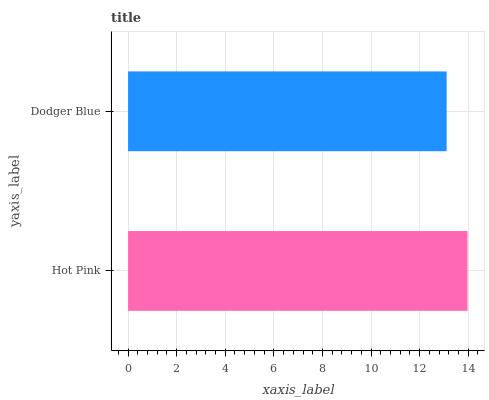Is Dodger Blue the minimum?
Answer yes or no. Yes. Is Hot Pink the maximum?
Answer yes or no. Yes. Is Dodger Blue the maximum?
Answer yes or no. No. Is Hot Pink greater than Dodger Blue?
Answer yes or no. Yes. Is Dodger Blue less than Hot Pink?
Answer yes or no. Yes. Is Dodger Blue greater than Hot Pink?
Answer yes or no. No. Is Hot Pink less than Dodger Blue?
Answer yes or no. No. Is Hot Pink the high median?
Answer yes or no. Yes. Is Dodger Blue the low median?
Answer yes or no. Yes. Is Dodger Blue the high median?
Answer yes or no. No. Is Hot Pink the low median?
Answer yes or no. No. 